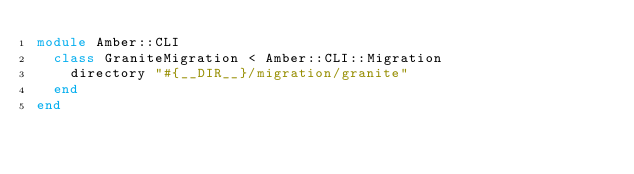Convert code to text. <code><loc_0><loc_0><loc_500><loc_500><_Crystal_>module Amber::CLI
  class GraniteMigration < Amber::CLI::Migration
    directory "#{__DIR__}/migration/granite"
  end
end
</code> 